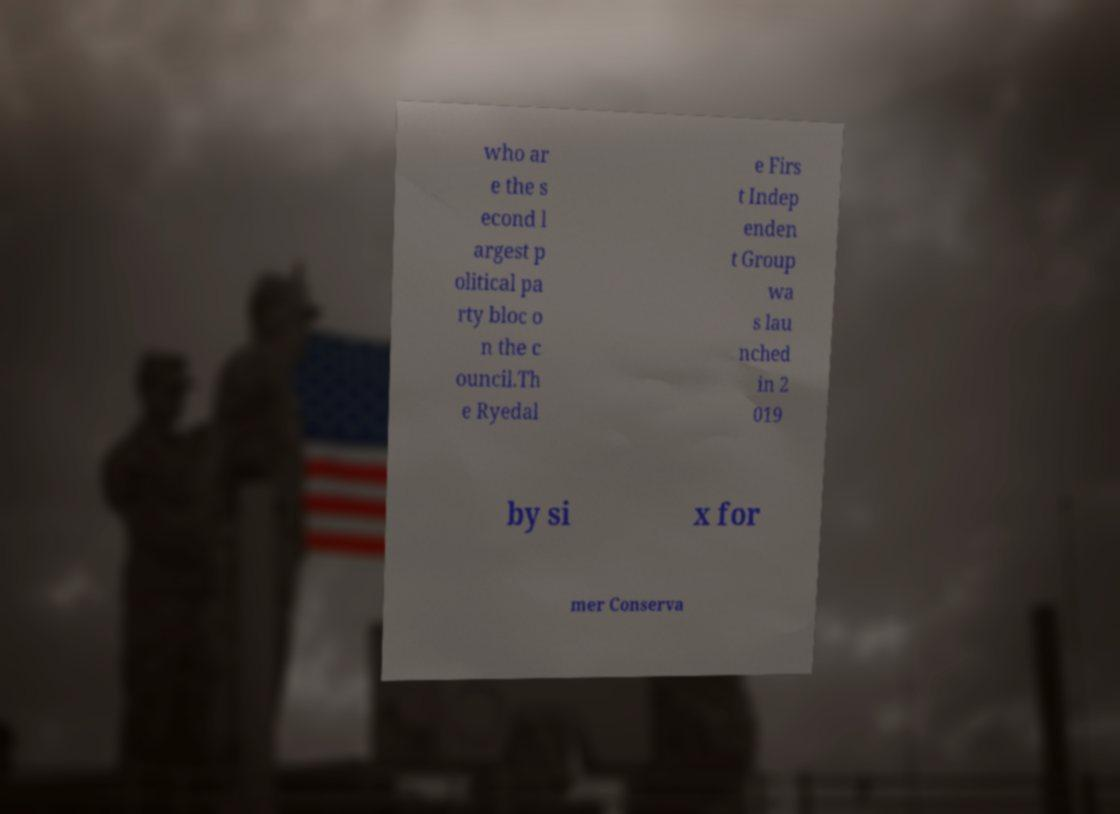Please read and relay the text visible in this image. What does it say? who ar e the s econd l argest p olitical pa rty bloc o n the c ouncil.Th e Ryedal e Firs t Indep enden t Group wa s lau nched in 2 019 by si x for mer Conserva 